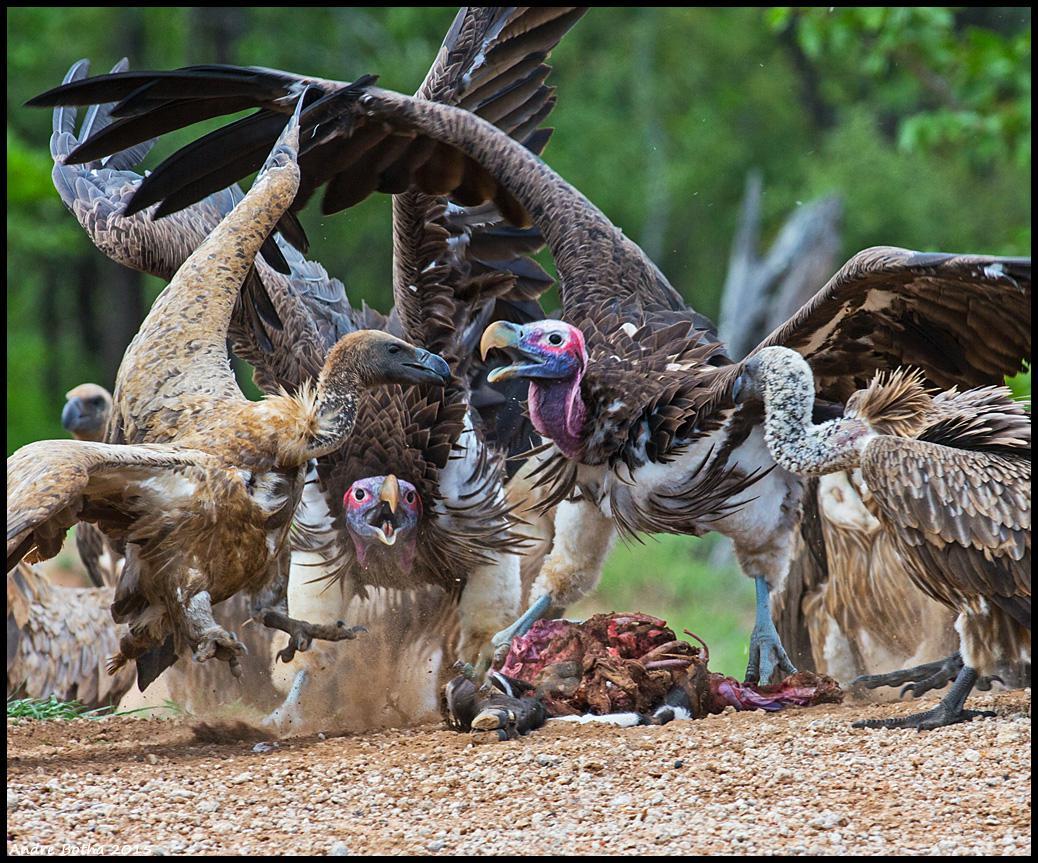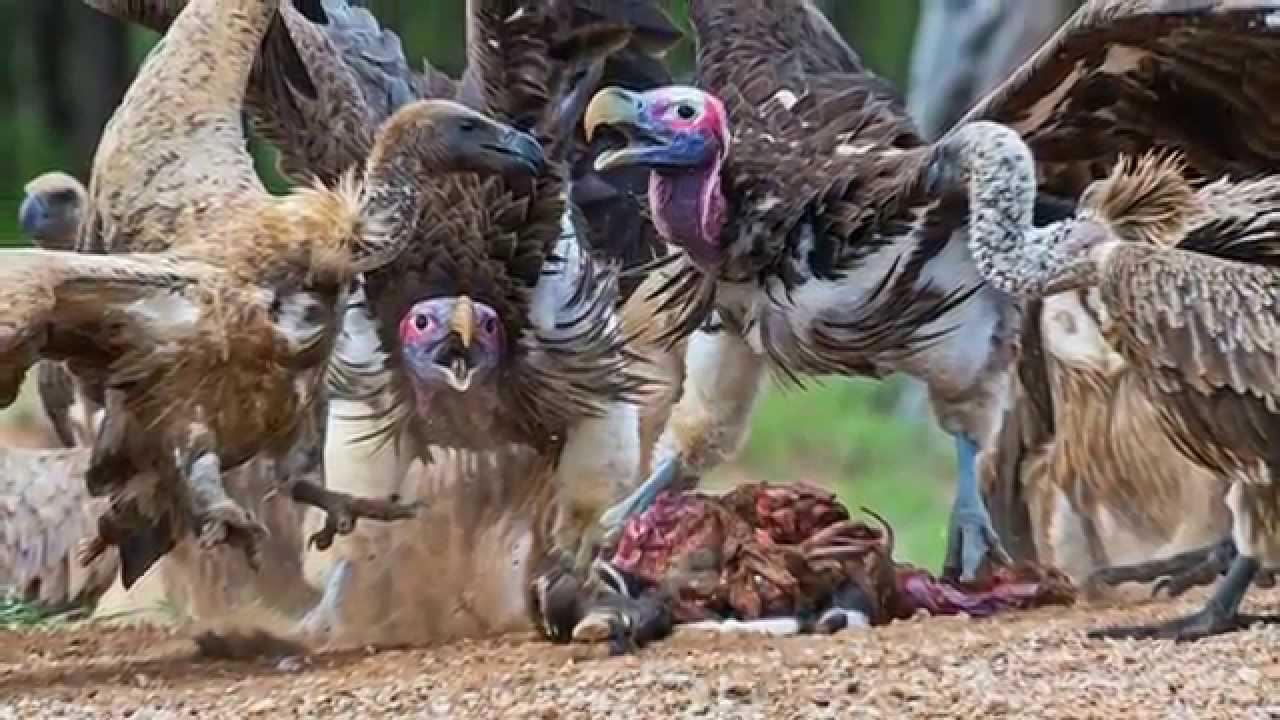The first image is the image on the left, the second image is the image on the right. Evaluate the accuracy of this statement regarding the images: "rows of dead vultures are in the grass with at least one human in the backgroud". Is it true? Answer yes or no. No. The first image is the image on the left, the second image is the image on the right. For the images displayed, is the sentence "there are humans in the pics" factually correct? Answer yes or no. No. 